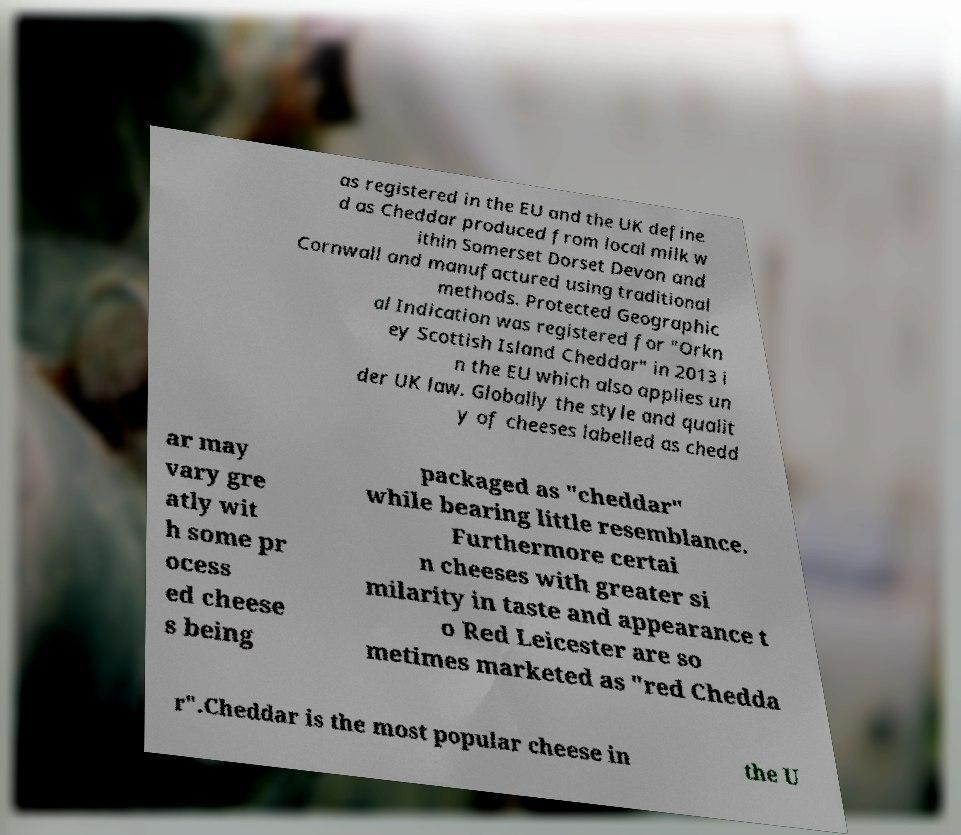Please identify and transcribe the text found in this image. as registered in the EU and the UK define d as Cheddar produced from local milk w ithin Somerset Dorset Devon and Cornwall and manufactured using traditional methods. Protected Geographic al Indication was registered for "Orkn ey Scottish Island Cheddar" in 2013 i n the EU which also applies un der UK law. Globally the style and qualit y of cheeses labelled as chedd ar may vary gre atly wit h some pr ocess ed cheese s being packaged as "cheddar" while bearing little resemblance. Furthermore certai n cheeses with greater si milarity in taste and appearance t o Red Leicester are so metimes marketed as "red Chedda r".Cheddar is the most popular cheese in the U 